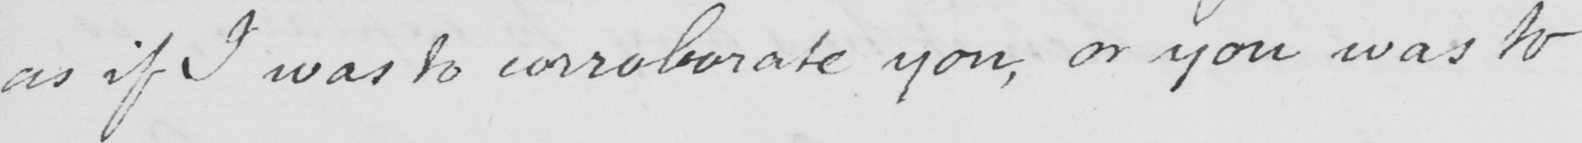What is written in this line of handwriting? as if I was to corroborate you , or you was to 